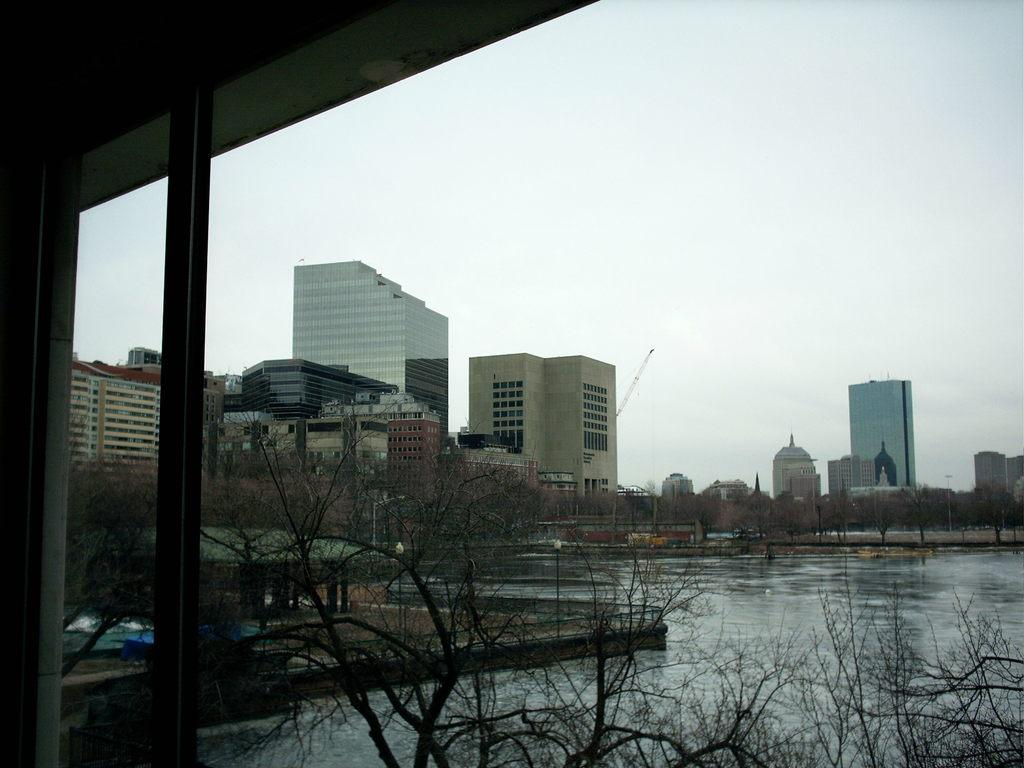What can be seen in the foreground of the picture? There are trees and a glass window in the foreground of the picture. What is located in the center of the picture? There are trees, buildings, grass, and a water body in the center of the picture. What is the condition of the sky in the picture? The sky is cloudy in the picture. What type of sound can be heard coming from the rod in the picture? There is no rod present in the image, and therefore no such sound can be heard. What type of apparel is being worn by the trees in the picture? Trees do not wear apparel, as they are plants and not people. 